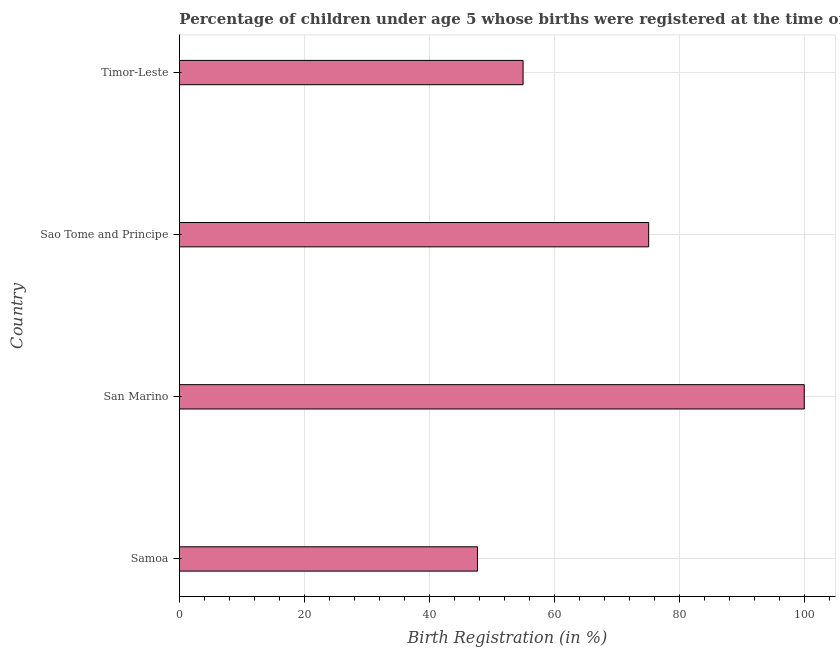Does the graph contain any zero values?
Your answer should be compact. No. Does the graph contain grids?
Offer a very short reply. Yes. What is the title of the graph?
Provide a succinct answer. Percentage of children under age 5 whose births were registered at the time of the survey in 2009. What is the label or title of the X-axis?
Keep it short and to the point. Birth Registration (in %). What is the label or title of the Y-axis?
Offer a very short reply. Country. What is the birth registration in Timor-Leste?
Provide a short and direct response. 55. Across all countries, what is the minimum birth registration?
Your answer should be very brief. 47.7. In which country was the birth registration maximum?
Keep it short and to the point. San Marino. In which country was the birth registration minimum?
Your response must be concise. Samoa. What is the sum of the birth registration?
Provide a short and direct response. 277.8. What is the difference between the birth registration in San Marino and Sao Tome and Principe?
Offer a very short reply. 24.9. What is the average birth registration per country?
Provide a short and direct response. 69.45. What is the median birth registration?
Give a very brief answer. 65.05. In how many countries, is the birth registration greater than 4 %?
Your response must be concise. 4. What is the ratio of the birth registration in San Marino to that in Sao Tome and Principe?
Your answer should be compact. 1.33. Is the birth registration in Sao Tome and Principe less than that in Timor-Leste?
Keep it short and to the point. No. Is the difference between the birth registration in Samoa and Sao Tome and Principe greater than the difference between any two countries?
Make the answer very short. No. What is the difference between the highest and the second highest birth registration?
Offer a terse response. 24.9. Is the sum of the birth registration in Samoa and San Marino greater than the maximum birth registration across all countries?
Offer a very short reply. Yes. What is the difference between the highest and the lowest birth registration?
Give a very brief answer. 52.3. Are all the bars in the graph horizontal?
Provide a succinct answer. Yes. Are the values on the major ticks of X-axis written in scientific E-notation?
Your response must be concise. No. What is the Birth Registration (in %) in Samoa?
Offer a very short reply. 47.7. What is the Birth Registration (in %) in San Marino?
Keep it short and to the point. 100. What is the Birth Registration (in %) in Sao Tome and Principe?
Your answer should be compact. 75.1. What is the difference between the Birth Registration (in %) in Samoa and San Marino?
Provide a short and direct response. -52.3. What is the difference between the Birth Registration (in %) in Samoa and Sao Tome and Principe?
Your answer should be compact. -27.4. What is the difference between the Birth Registration (in %) in Samoa and Timor-Leste?
Give a very brief answer. -7.3. What is the difference between the Birth Registration (in %) in San Marino and Sao Tome and Principe?
Give a very brief answer. 24.9. What is the difference between the Birth Registration (in %) in San Marino and Timor-Leste?
Keep it short and to the point. 45. What is the difference between the Birth Registration (in %) in Sao Tome and Principe and Timor-Leste?
Offer a terse response. 20.1. What is the ratio of the Birth Registration (in %) in Samoa to that in San Marino?
Offer a very short reply. 0.48. What is the ratio of the Birth Registration (in %) in Samoa to that in Sao Tome and Principe?
Ensure brevity in your answer.  0.64. What is the ratio of the Birth Registration (in %) in Samoa to that in Timor-Leste?
Your answer should be compact. 0.87. What is the ratio of the Birth Registration (in %) in San Marino to that in Sao Tome and Principe?
Offer a very short reply. 1.33. What is the ratio of the Birth Registration (in %) in San Marino to that in Timor-Leste?
Your answer should be very brief. 1.82. What is the ratio of the Birth Registration (in %) in Sao Tome and Principe to that in Timor-Leste?
Keep it short and to the point. 1.36. 